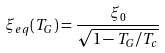Convert formula to latex. <formula><loc_0><loc_0><loc_500><loc_500>\xi _ { e q } ( T _ { G } ) = \frac { \xi _ { 0 } } { \sqrt { 1 - T _ { G } / T _ { c } } }</formula> 